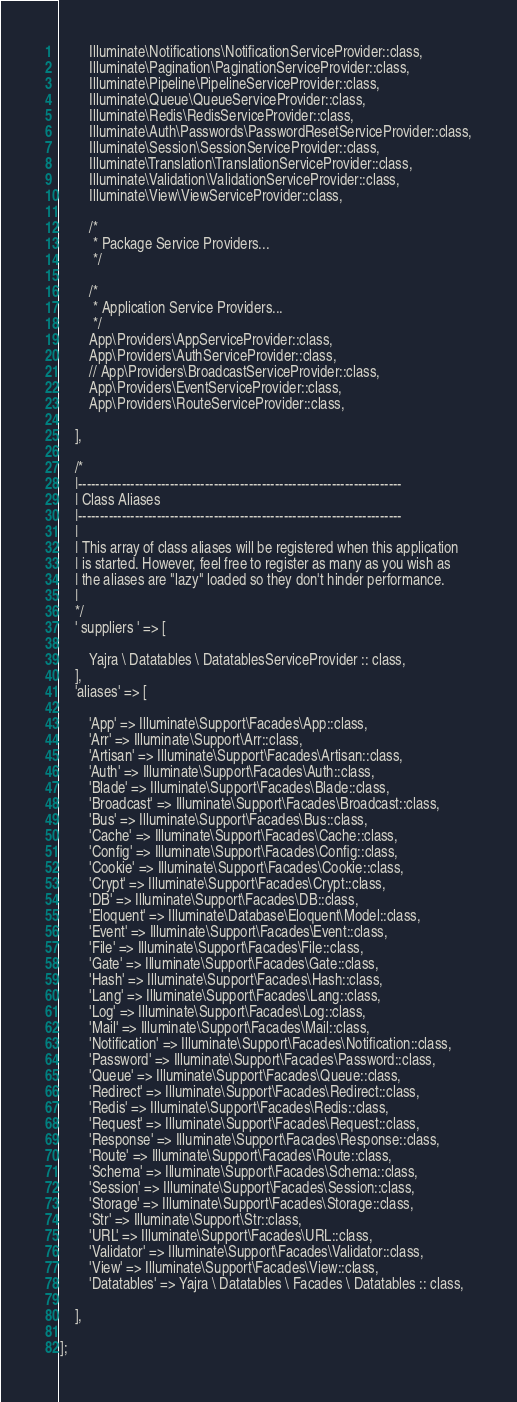<code> <loc_0><loc_0><loc_500><loc_500><_PHP_>        Illuminate\Notifications\NotificationServiceProvider::class,
        Illuminate\Pagination\PaginationServiceProvider::class,
        Illuminate\Pipeline\PipelineServiceProvider::class,
        Illuminate\Queue\QueueServiceProvider::class,
        Illuminate\Redis\RedisServiceProvider::class,
        Illuminate\Auth\Passwords\PasswordResetServiceProvider::class,
        Illuminate\Session\SessionServiceProvider::class,
        Illuminate\Translation\TranslationServiceProvider::class,
        Illuminate\Validation\ValidationServiceProvider::class,
        Illuminate\View\ViewServiceProvider::class,

        /*
         * Package Service Providers...
         */

        /*
         * Application Service Providers...
         */
        App\Providers\AppServiceProvider::class,
        App\Providers\AuthServiceProvider::class,
        // App\Providers\BroadcastServiceProvider::class,
        App\Providers\EventServiceProvider::class,
        App\Providers\RouteServiceProvider::class,

    ],

    /*
    |--------------------------------------------------------------------------
    | Class Aliases
    |--------------------------------------------------------------------------
    |
    | This array of class aliases will be registered when this application
    | is started. However, feel free to register as many as you wish as
    | the aliases are "lazy" loaded so they don't hinder performance.
    |
    */
    ' suppliers ' => [

        Yajra \ Datatables \ DatatablesServiceProvider :: class,
    ],
    'aliases' => [

        'App' => Illuminate\Support\Facades\App::class,
        'Arr' => Illuminate\Support\Arr::class,
        'Artisan' => Illuminate\Support\Facades\Artisan::class,
        'Auth' => Illuminate\Support\Facades\Auth::class,
        'Blade' => Illuminate\Support\Facades\Blade::class,
        'Broadcast' => Illuminate\Support\Facades\Broadcast::class,
        'Bus' => Illuminate\Support\Facades\Bus::class,
        'Cache' => Illuminate\Support\Facades\Cache::class,
        'Config' => Illuminate\Support\Facades\Config::class,
        'Cookie' => Illuminate\Support\Facades\Cookie::class,
        'Crypt' => Illuminate\Support\Facades\Crypt::class,
        'DB' => Illuminate\Support\Facades\DB::class,
        'Eloquent' => Illuminate\Database\Eloquent\Model::class,
        'Event' => Illuminate\Support\Facades\Event::class,
        'File' => Illuminate\Support\Facades\File::class,
        'Gate' => Illuminate\Support\Facades\Gate::class,
        'Hash' => Illuminate\Support\Facades\Hash::class,
        'Lang' => Illuminate\Support\Facades\Lang::class,
        'Log' => Illuminate\Support\Facades\Log::class,
        'Mail' => Illuminate\Support\Facades\Mail::class,
        'Notification' => Illuminate\Support\Facades\Notification::class,
        'Password' => Illuminate\Support\Facades\Password::class,
        'Queue' => Illuminate\Support\Facades\Queue::class,
        'Redirect' => Illuminate\Support\Facades\Redirect::class,
        'Redis' => Illuminate\Support\Facades\Redis::class,
        'Request' => Illuminate\Support\Facades\Request::class,
        'Response' => Illuminate\Support\Facades\Response::class,
        'Route' => Illuminate\Support\Facades\Route::class,
        'Schema' => Illuminate\Support\Facades\Schema::class,
        'Session' => Illuminate\Support\Facades\Session::class,
        'Storage' => Illuminate\Support\Facades\Storage::class,
        'Str' => Illuminate\Support\Str::class,
        'URL' => Illuminate\Support\Facades\URL::class,
        'Validator' => Illuminate\Support\Facades\Validator::class,
        'View' => Illuminate\Support\Facades\View::class,
        'Datatables' => Yajra \ Datatables \ Facades \ Datatables :: class,

    ],

];
</code> 